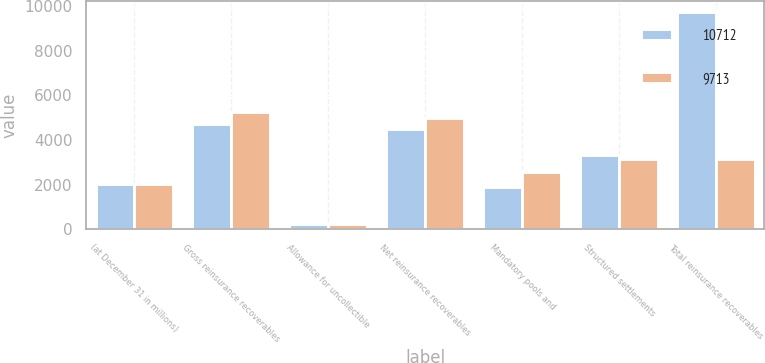<chart> <loc_0><loc_0><loc_500><loc_500><stacked_bar_chart><ecel><fcel>(at December 31 in millions)<fcel>Gross reinsurance recoverables<fcel>Allowance for uncollectible<fcel>Net reinsurance recoverables<fcel>Mandatory pools and<fcel>Structured settlements<fcel>Total reinsurance recoverables<nl><fcel>10712<fcel>2013<fcel>4707<fcel>239<fcel>4468<fcel>1897<fcel>3348<fcel>9713<nl><fcel>9713<fcel>2012<fcel>5256<fcel>258<fcel>4998<fcel>2549<fcel>3165<fcel>3165<nl></chart> 